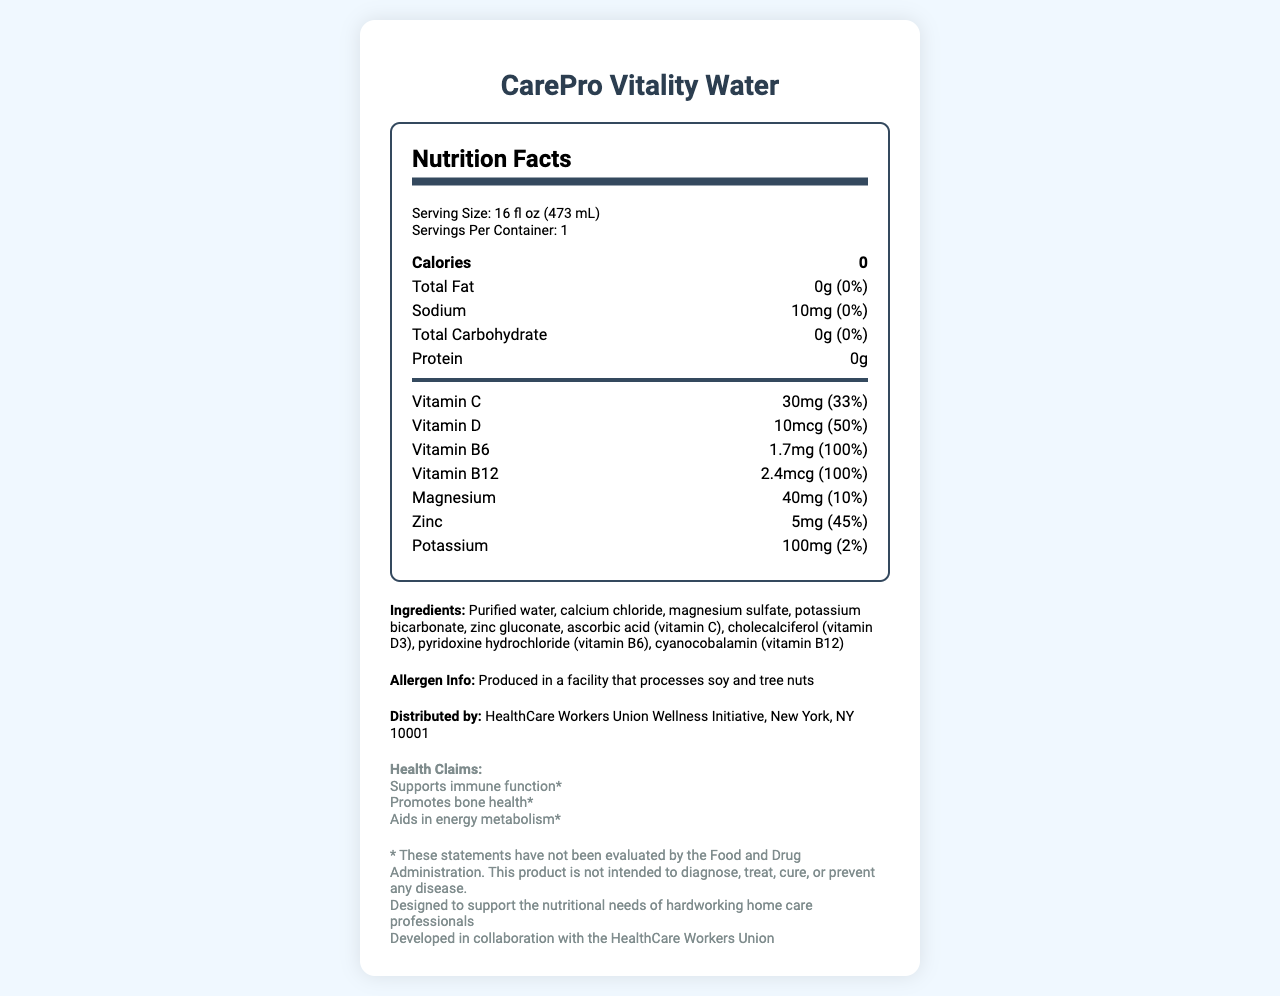What is the serving size of CarePro Vitality Water? The serving size is explicitly mentioned in the "Serving Size" section of the document.
Answer: 16 fl oz (473 mL) How much sodium is in a serving of CarePro Vitality Water? The amount of sodium per serving is listed as 10mg in the nutrition facts.
Answer: 10mg What percentage of the daily value of Vitamin D is in one serving? The document states that one serving provides 10mcg of Vitamin D, which is 50% of the daily value.
Answer: 50% Which vitamin has the highest daily value percentage? Both Vitamin B6 and Vitamin B12 each have a daily value percentage of 100%, which is the highest among the listed vitamins and minerals.
Answer: Vitamin B6 and Vitamin B12 List all the minerals present in CarePro Vitality Water. The minerals listed in the document under the vitamins and minerals section are Magnesium (40mg, 10%), Zinc (5mg, 45%), and Potassium (100mg, 2%).
Answer: Magnesium, Zinc, Potassium Is the product calorie-free? The nutrition label lists the calorie content as 0, indicating that the product is calorie-free.
Answer: Yes Who distributes CarePro Vitality Water? The distributor of the product is listed at the bottom of the document under the distributor section.
Answer: HealthCare Workers Union Wellness Initiative, New York, NY 10001 Which of the following is NOT a health claim made by CarePro Vitality Water? A. Supports immune function B. Improves vision C. Promotes bone health D. Aids in energy metabolism The health claims listed are "Supports immune function", "Promotes bone health", and "Aids in energy metabolism". "Improves vision" is not mentioned.
Answer: B What ingredient is the main source of Vitamin C in the product? A. Calcium chloride B. Zinc gluconate C. Ascorbic acid D. Cholecalciferol Ascorbic acid is the source of Vitamin C, as referenced in the ingredients list.
Answer: C Which vitamin helps in energy metabolism according to the health claims? A. Vitamin C B. Vitamin D C. Vitamin B6 D. Vitamin B12 The health claim "Aids in energy metabolism" is related to Vitamin B6, known for its role in energy metabolism.
Answer: C Is the product designed specifically for home care professionals? The additional info section states that the product is designed to support the nutritional needs of hardworking home care professionals.
Answer: Yes Summarize the main idea of the document. The summary captures all the key information from the document, including the product name, nutrient content, target audience, ingredients, and health claims.
Answer: The document is a nutrition facts label for "CarePro Vitality Water", a fortified bottled water. It provides detailed information on serving size, calorie content, and nutrients including vitamins and minerals. The product has 0 calories and is rich in various vitamins and minerals, specifically targeting home care professionals. The label also includes ingredients, allergen information, distributor information, and health claims while emphasizing that certain statements have not been evaluated by the FDA. Where was CarePro Vitality Water manufactured? The document provides information on the distributor but does not specify the manufacturing location.
Answer: Cannot be determined 